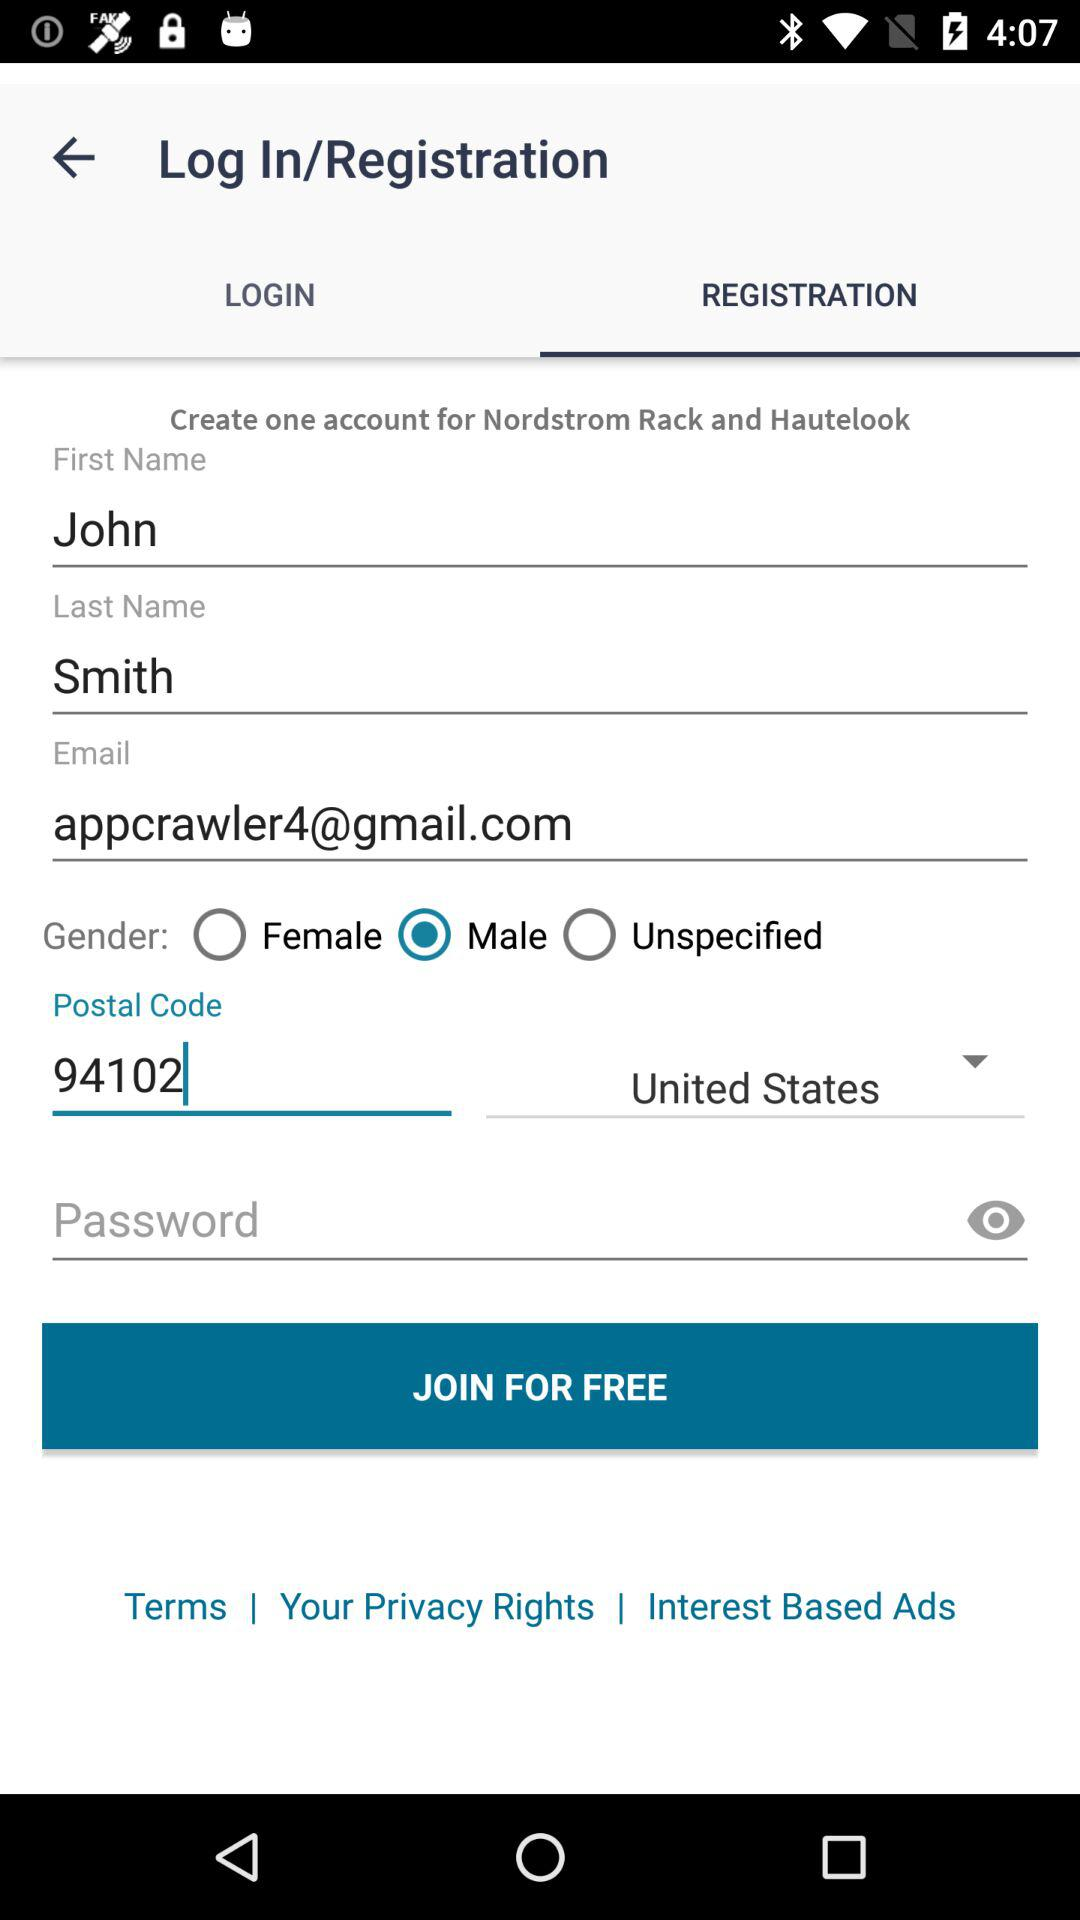What is the selected country? The selected country is the United States. 